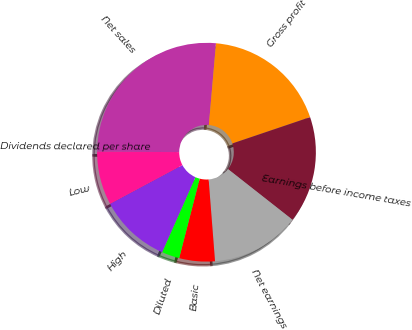<chart> <loc_0><loc_0><loc_500><loc_500><pie_chart><fcel>Net sales<fcel>Gross profit<fcel>Earnings before income taxes<fcel>Net earnings<fcel>Basic<fcel>Diluted<fcel>High<fcel>Low<fcel>Dividends declared per share<nl><fcel>26.31%<fcel>18.42%<fcel>15.79%<fcel>13.16%<fcel>5.26%<fcel>2.63%<fcel>10.53%<fcel>7.9%<fcel>0.0%<nl></chart> 